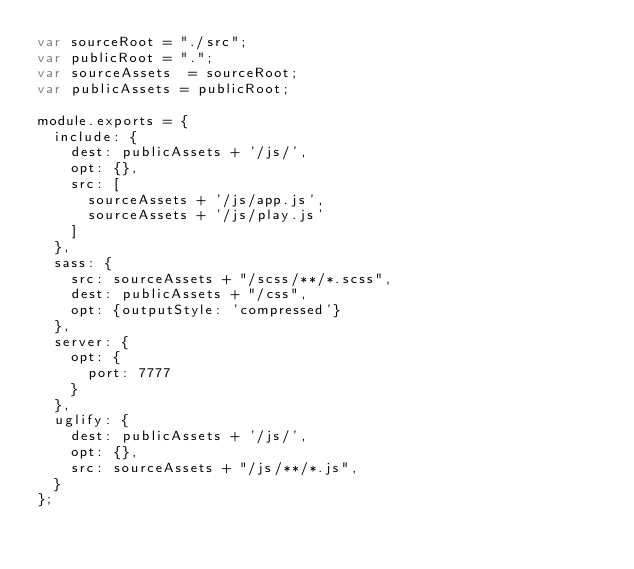<code> <loc_0><loc_0><loc_500><loc_500><_JavaScript_>var sourceRoot = "./src";
var publicRoot = ".";
var sourceAssets  = sourceRoot;
var publicAssets = publicRoot;

module.exports = {
  include: {
    dest: publicAssets + '/js/',
    opt: {},
    src: [
      sourceAssets + '/js/app.js',
      sourceAssets + '/js/play.js'
    ]
  },
  sass: {
    src: sourceAssets + "/scss/**/*.scss",
    dest: publicAssets + "/css",
    opt: {outputStyle: 'compressed'}
  },
  server: {
    opt: {
      port: 7777
    }
  },
  uglify: {
    dest: publicAssets + '/js/',
    opt: {},
    src: sourceAssets + "/js/**/*.js",
  }
};
</code> 